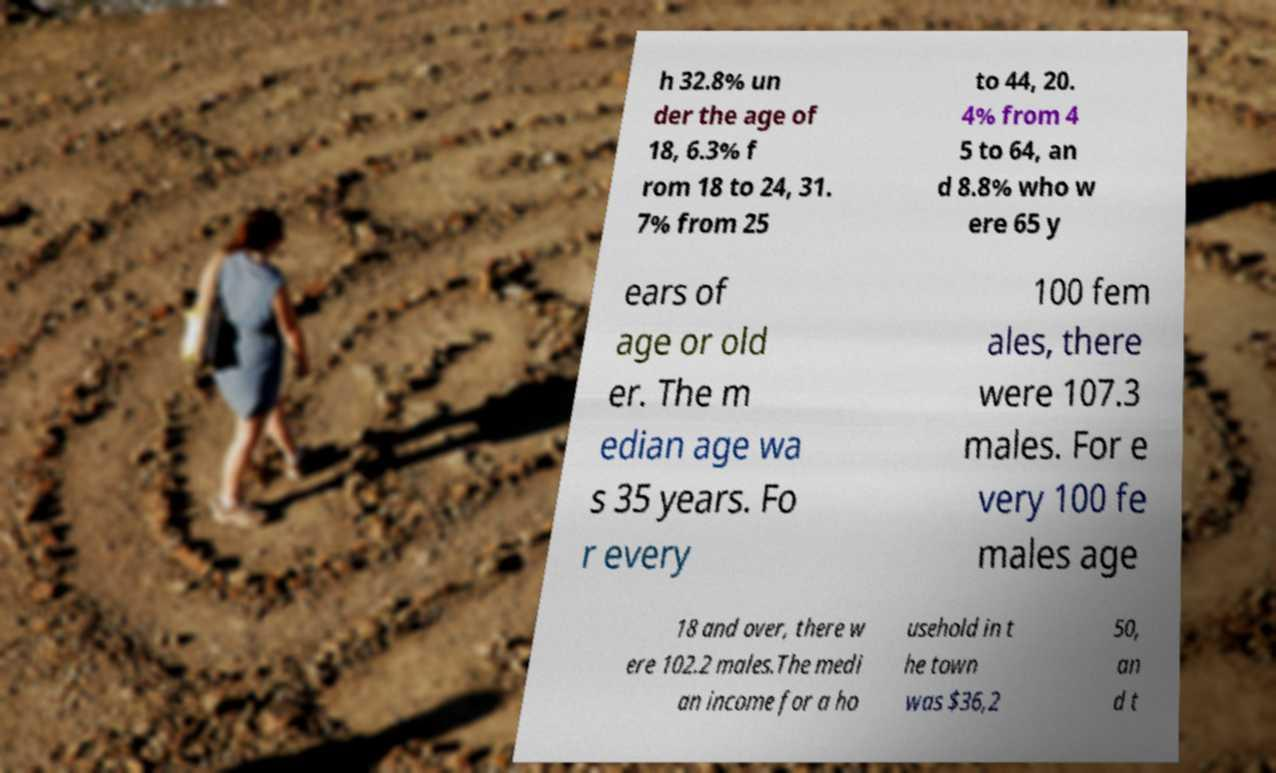Can you accurately transcribe the text from the provided image for me? h 32.8% un der the age of 18, 6.3% f rom 18 to 24, 31. 7% from 25 to 44, 20. 4% from 4 5 to 64, an d 8.8% who w ere 65 y ears of age or old er. The m edian age wa s 35 years. Fo r every 100 fem ales, there were 107.3 males. For e very 100 fe males age 18 and over, there w ere 102.2 males.The medi an income for a ho usehold in t he town was $36,2 50, an d t 